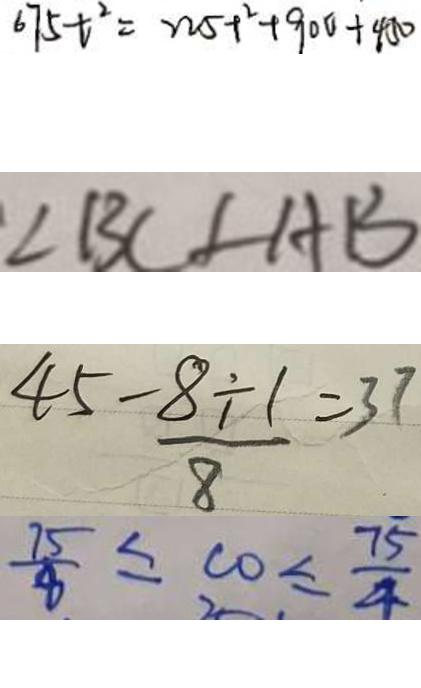<formula> <loc_0><loc_0><loc_500><loc_500>6 7 5 t ^ { 2 } = 2 2 5 + ^ { 2 } + 9 0 0 + 4 5 0 
 \angle B C \angle A B 
 4 5 - \frac { 8 \div 1 } { 8 } = 3 7 
 \frac { 7 5 } { 8 } \leq c o \leq \frac { 7 5 } { 4 }</formula> 